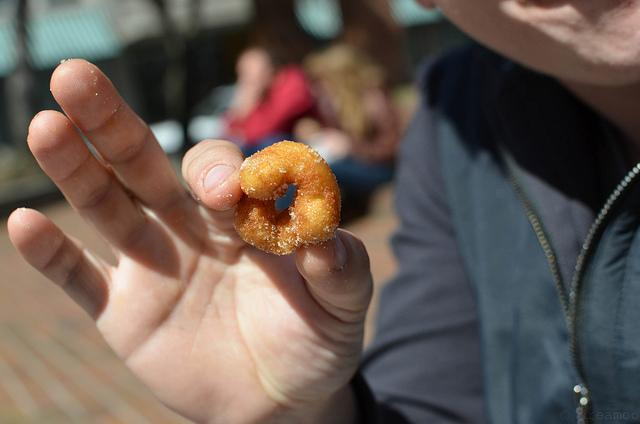What is the man holding? Please explain your reasoning. zeppole. That is the foo the man is holding. 